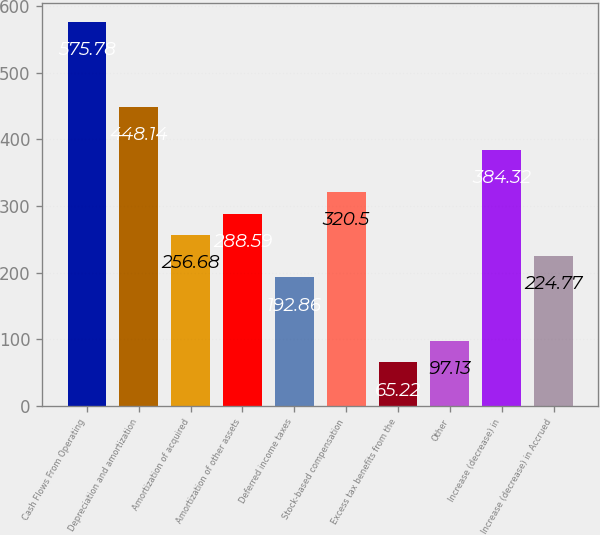<chart> <loc_0><loc_0><loc_500><loc_500><bar_chart><fcel>Cash Flows From Operating<fcel>Depreciation and amortization<fcel>Amortization of acquired<fcel>Amortization of other assets<fcel>Deferred income taxes<fcel>Stock-based compensation<fcel>Excess tax benefits from the<fcel>Other<fcel>Increase (decrease) in<fcel>Increase (decrease) in Accrued<nl><fcel>575.78<fcel>448.14<fcel>256.68<fcel>288.59<fcel>192.86<fcel>320.5<fcel>65.22<fcel>97.13<fcel>384.32<fcel>224.77<nl></chart> 